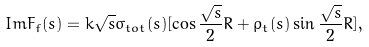Convert formula to latex. <formula><loc_0><loc_0><loc_500><loc_500>I m F _ { f } ( s ) = k \sqrt { s } \sigma _ { t o t } ( s ) [ \cos \frac { \sqrt { s } } { 2 } R + \rho _ { t } ( s ) \sin \frac { \sqrt { s } } { 2 } R ] ,</formula> 